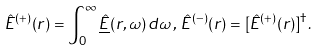Convert formula to latex. <formula><loc_0><loc_0><loc_500><loc_500>\hat { E } ^ { ( + ) } ( r ) = \int _ { 0 } ^ { \infty } \underline { \hat { E } } ( r , \omega ) \, d \omega \, , \, \hat { E } ^ { ( - ) } ( r ) = [ \hat { E } ^ { ( + ) } ( r ) ] ^ { \dag } .</formula> 